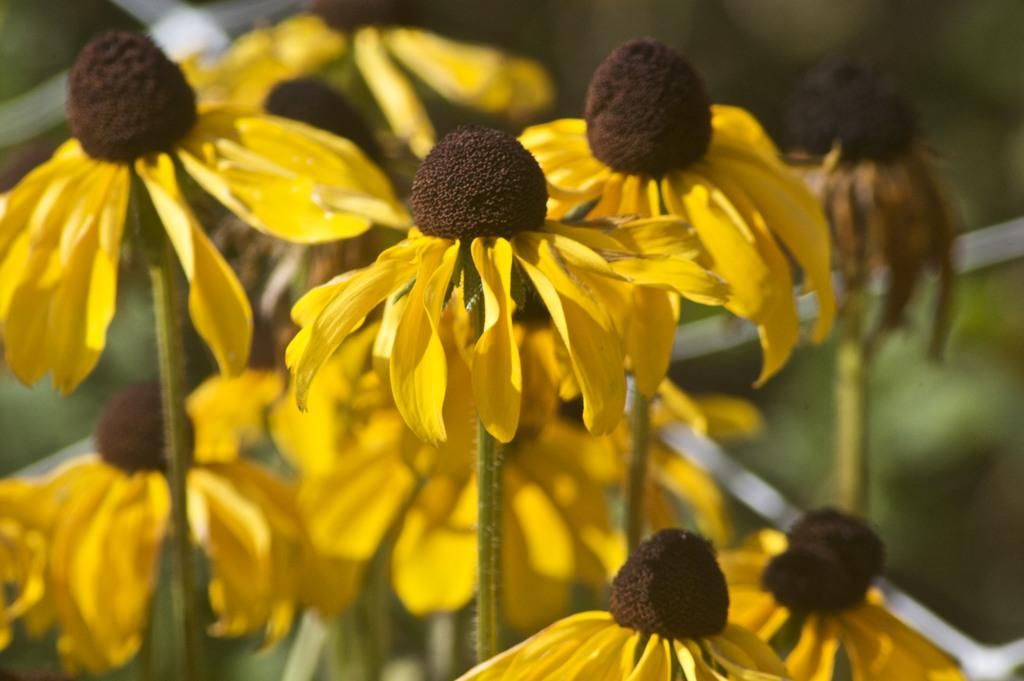What type of plants can be seen in the image? There are flowers in the image. What color are the petals of the flowers? The flowers have yellow petals. What is the color of the center of the flowers? The flowers have a brown center. How are the flowers attached to the ground or surface? The flowers are on stems. How do the flowers demonstrate their love for the giants in the image? There are no giants or any indication of love present in the image; it only features flowers with yellow petals and a brown center. 